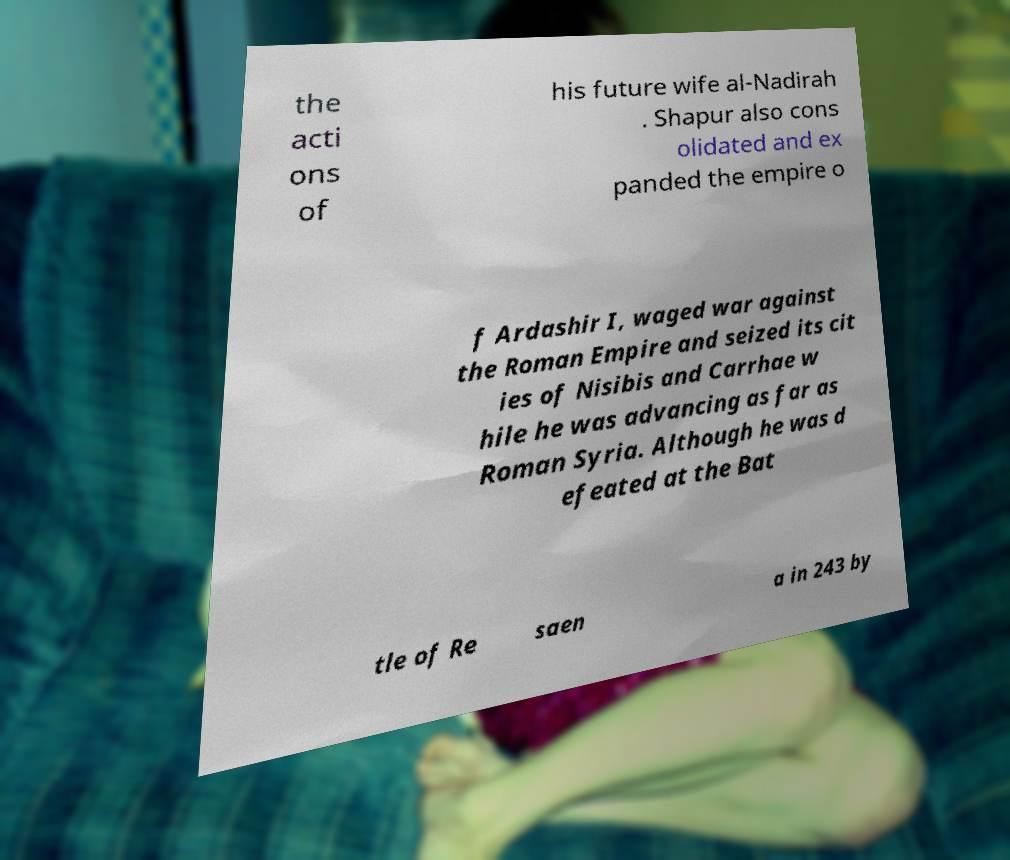What messages or text are displayed in this image? I need them in a readable, typed format. the acti ons of his future wife al-Nadirah . Shapur also cons olidated and ex panded the empire o f Ardashir I, waged war against the Roman Empire and seized its cit ies of Nisibis and Carrhae w hile he was advancing as far as Roman Syria. Although he was d efeated at the Bat tle of Re saen a in 243 by 